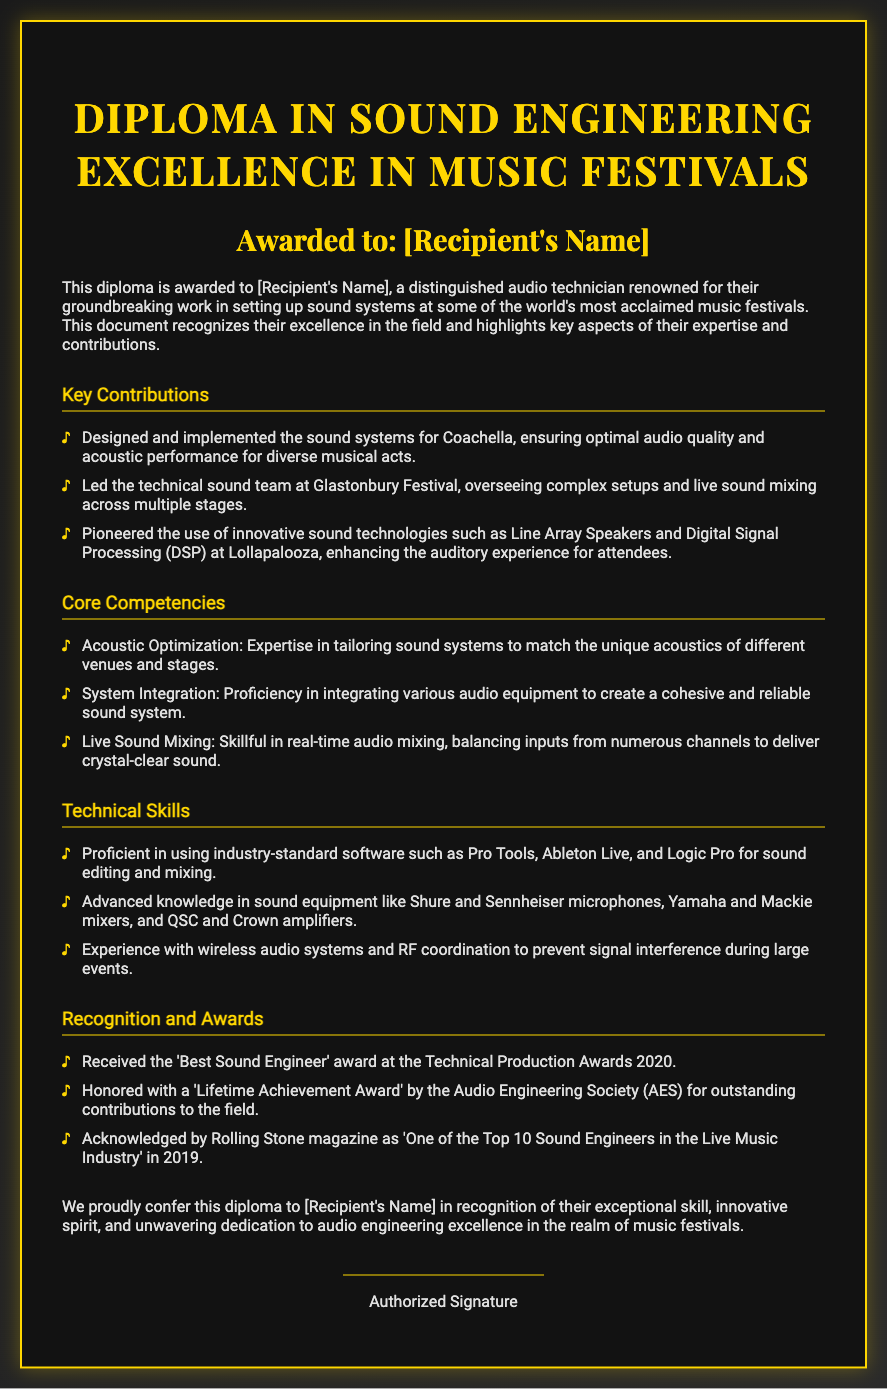What is the title of the diploma? The title of the diploma is mentioned at the top of the document, indicating the focus on Sound Engineering Excellence in Music Festivals.
Answer: Diploma in Sound Engineering Excellence in Music Festivals Who is the recipient of the diploma? The recipient's name is indicated as "[Recipient's Name]" in the document, which will be replaced with the actual name.
Answer: [Recipient's Name] Which festival did the audio technician lead the technical sound team? The document specifies that the technician led the team at Glastonbury Festival, highlighting their role and responsibility there.
Answer: Glastonbury Festival What award did the recipient receive in 2020? The document states that the recipient was awarded 'Best Sound Engineer' at the Technical Production Awards in 2020.
Answer: Best Sound Engineer What innovative technologies were pioneered at Lollapalooza? The document mentions that innovative sound technologies like Line Array Speakers and Digital Signal Processing (DSP) were used at Lollapalooza, showcasing the advancements in their sound systems.
Answer: Line Array Speakers and Digital Signal Processing (DSP) What is one of the technical skills mentioned for the recipient? The document lists several technical skills, including proficiency in industry-standard software for sound editing and mixing as key competencies.
Answer: Proficient in using industry-standard software How does the diploma recognize the recipient’s contributions? The diploma acknowledges the recipient's exceptional skill and innovative spirit in audio engineering, highlighting their dedication to excellence in music festivals.
Answer: Exceptional skill and innovative spirit What type of document is this? The document is a formal certificate that acknowledges the achievements and contributions of an individual in a specific field.
Answer: Diploma 